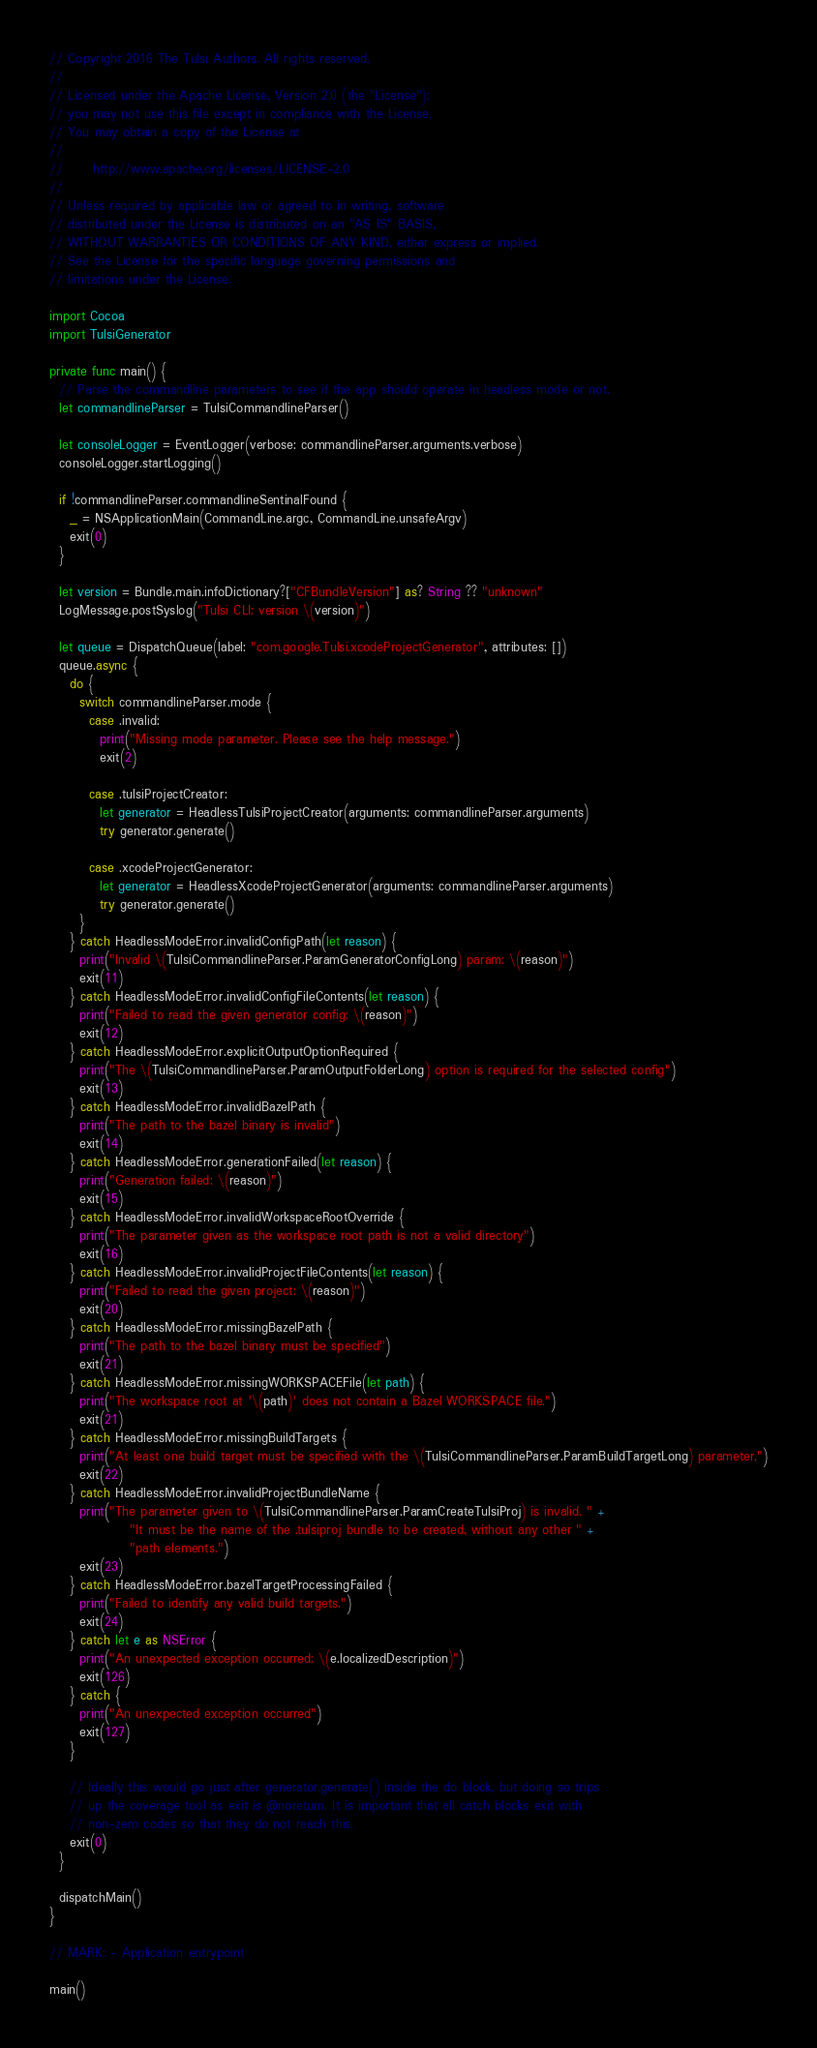<code> <loc_0><loc_0><loc_500><loc_500><_Swift_>// Copyright 2016 The Tulsi Authors. All rights reserved.
//
// Licensed under the Apache License, Version 2.0 (the "License");
// you may not use this file except in compliance with the License.
// You may obtain a copy of the License at
//
//      http://www.apache.org/licenses/LICENSE-2.0
//
// Unless required by applicable law or agreed to in writing, software
// distributed under the License is distributed on an "AS IS" BASIS,
// WITHOUT WARRANTIES OR CONDITIONS OF ANY KIND, either express or implied.
// See the License for the specific language governing permissions and
// limitations under the License.

import Cocoa
import TulsiGenerator

private func main() {
  // Parse the commandline parameters to see if the app should operate in headless mode or not.
  let commandlineParser = TulsiCommandlineParser()

  let consoleLogger = EventLogger(verbose: commandlineParser.arguments.verbose)
  consoleLogger.startLogging()

  if !commandlineParser.commandlineSentinalFound {
    _ = NSApplicationMain(CommandLine.argc, CommandLine.unsafeArgv)
    exit(0)
  }

  let version = Bundle.main.infoDictionary?["CFBundleVersion"] as? String ?? "unknown"
  LogMessage.postSyslog("Tulsi CLI: version \(version)")

  let queue = DispatchQueue(label: "com.google.Tulsi.xcodeProjectGenerator", attributes: [])
  queue.async {
    do {
      switch commandlineParser.mode {
        case .invalid:
          print("Missing mode parameter. Please see the help message.")
          exit(2)

        case .tulsiProjectCreator:
          let generator = HeadlessTulsiProjectCreator(arguments: commandlineParser.arguments)
          try generator.generate()

        case .xcodeProjectGenerator:
          let generator = HeadlessXcodeProjectGenerator(arguments: commandlineParser.arguments)
          try generator.generate()
      }
    } catch HeadlessModeError.invalidConfigPath(let reason) {
      print("Invalid \(TulsiCommandlineParser.ParamGeneratorConfigLong) param: \(reason)")
      exit(11)
    } catch HeadlessModeError.invalidConfigFileContents(let reason) {
      print("Failed to read the given generator config: \(reason)")
      exit(12)
    } catch HeadlessModeError.explicitOutputOptionRequired {
      print("The \(TulsiCommandlineParser.ParamOutputFolderLong) option is required for the selected config")
      exit(13)
    } catch HeadlessModeError.invalidBazelPath {
      print("The path to the bazel binary is invalid")
      exit(14)
    } catch HeadlessModeError.generationFailed(let reason) {
      print("Generation failed: \(reason)")
      exit(15)
    } catch HeadlessModeError.invalidWorkspaceRootOverride {
      print("The parameter given as the workspace root path is not a valid directory")
      exit(16)
    } catch HeadlessModeError.invalidProjectFileContents(let reason) {
      print("Failed to read the given project: \(reason)")
      exit(20)
    } catch HeadlessModeError.missingBazelPath {
      print("The path to the bazel binary must be specified")
      exit(21)
    } catch HeadlessModeError.missingWORKSPACEFile(let path) {
      print("The workspace root at '\(path)' does not contain a Bazel WORKSPACE file.")
      exit(21)
    } catch HeadlessModeError.missingBuildTargets {
      print("At least one build target must be specified with the \(TulsiCommandlineParser.ParamBuildTargetLong) parameter.")
      exit(22)
    } catch HeadlessModeError.invalidProjectBundleName {
      print("The parameter given to \(TulsiCommandlineParser.ParamCreateTulsiProj) is invalid. " +
                "It must be the name of the .tulsiproj bundle to be created, without any other " +
                "path elements.")
      exit(23)
    } catch HeadlessModeError.bazelTargetProcessingFailed {
      print("Failed to identify any valid build targets.")
      exit(24)
    } catch let e as NSError {
      print("An unexpected exception occurred: \(e.localizedDescription)")
      exit(126)
    } catch {
      print("An unexpected exception occurred")
      exit(127)
    }

    // Ideally this would go just after generator.generate() inside the do block, but doing so trips
    // up the coverage tool as exit is @noreturn. It is important that all catch blocks exit with
    // non-zero codes so that they do not reach this.
    exit(0)
  }

  dispatchMain()
}

// MARK: - Application entrypoint

main()
</code> 